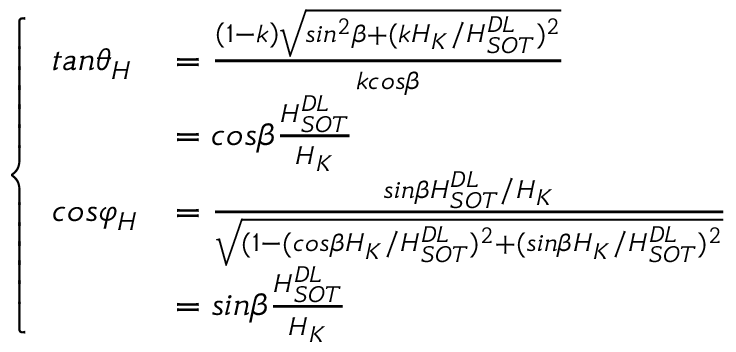Convert formula to latex. <formula><loc_0><loc_0><loc_500><loc_500>\left \{ \begin{array} { l l } { t a n { \theta } _ { H } } & { = \frac { \left ( 1 - k \right ) \sqrt { \sin ^ { 2 } \beta + ( k H _ { K } / H _ { S O T } ^ { D L } ) ^ { 2 } } } { k \cos \beta } } \\ & { = \cos \beta \frac { H _ { S O T } ^ { D L } } { H _ { K } } } \\ { \cos { \varphi } _ { H } } & { = \frac { \sin \beta H _ { S O T } ^ { D L } / H _ { K } } { \sqrt { ( 1 - ( \cos \beta H _ { K } / H _ { S O T } ^ { D L } ) ^ { 2 } + ( \sin \beta H _ { K } / H _ { S O T } ^ { D L } ) ^ { 2 } } } } \\ & { = \sin \beta \frac { H _ { S O T } ^ { D L } } { H _ { K } } } \end{array}</formula> 